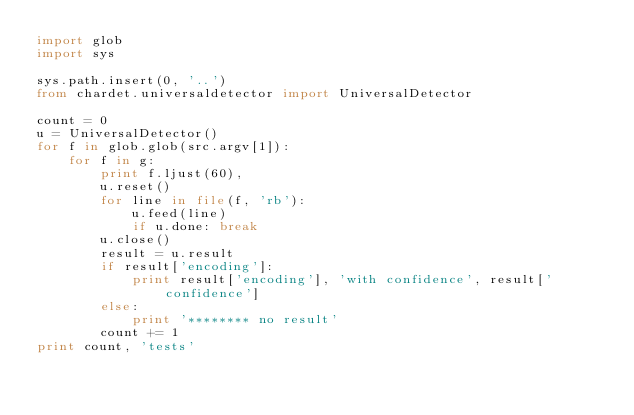Convert code to text. <code><loc_0><loc_0><loc_500><loc_500><_Python_>import glob
import sys

sys.path.insert(0, '..')
from chardet.universaldetector import UniversalDetector

count = 0
u = UniversalDetector()
for f in glob.glob(src.argv[1]):
    for f in g:
        print f.ljust(60),
        u.reset()
        for line in file(f, 'rb'):
            u.feed(line)
            if u.done: break
        u.close()
        result = u.result
        if result['encoding']:
            print result['encoding'], 'with confidence', result['confidence']
        else:
            print '******** no result'
        count += 1
print count, 'tests'
</code> 